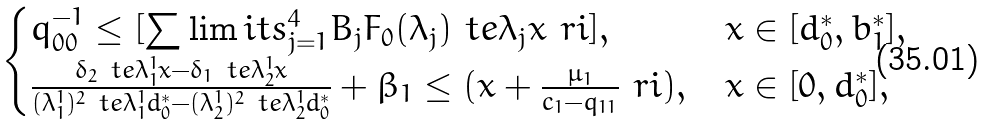Convert formula to latex. <formula><loc_0><loc_0><loc_500><loc_500>\begin{cases} q _ { 0 0 } ^ { - 1 } \leq [ \sum \lim i t s _ { j = 1 } ^ { 4 } B _ { j } F _ { 0 } ( \lambda _ { j } ) \ t e { \lambda _ { j } x } \ r i ] , & x \in [ d ^ { * } _ { 0 } , b ^ { * } _ { 1 } ] , \\ \frac { \delta _ { 2 } \ t e { \lambda _ { 1 } ^ { 1 } x } - \delta _ { 1 } \ t e { \lambda _ { 2 } ^ { 1 } x } } { ( \lambda _ { 1 } ^ { 1 } ) ^ { 2 } \ t e { \lambda _ { 1 } ^ { 1 } d ^ { * } _ { 0 } } - ( \lambda _ { 2 } ^ { 1 } ) ^ { 2 } \ t e { \lambda _ { 2 } ^ { 1 } d ^ { * } _ { 0 } } } + \beta _ { 1 } \leq ( x + \frac { \mu _ { 1 } } { c _ { 1 } - q _ { 1 1 } } \ r i ) , & x \in [ 0 , d ^ { * } _ { 0 } ] , \end{cases}</formula> 